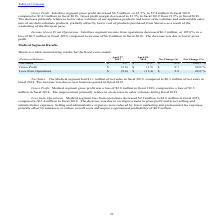According to Methode Electronics's financial document, What led to improvement in medical segment gross profit during fiscal 2019? an increase in sales volumes during fiscal 2019.. The document states: "fiscal 2018. The improvement primarily relates to an increase in sales volumes during fiscal 2019...." Also, can you calculate: What is the average Gross Profit for Fiscal Year Ended April 28, 2018 to Fiscal Year Ended April 27, 2019? To answer this question, I need to perform calculations using the financial data. The calculation is: -(2.8+3.5) / 2, which equals -3.15 (in millions). This is based on the information: "Gross Profit $ (2.8) $ (3.5) $ 0.7 20.0 % in fiscal 2018. Gross profit margin decreased to 13.5% in fiscal 2019 from 19.5% in fiscal 2018. The decrease primarily relates to lower sales volumes of..." The key data points involved are: 2.8, 3.5. Also, can you calculate: What is the average Loss from Operations for Fiscal Year Ended April 28, 2018 to Fiscal Year Ended April 27, 2019? To answer this question, I need to perform calculations using the financial data. The calculation is: -(8.6+11.4) / 2, which equals -10 (in millions). This is based on the information: "Loss from Operations $ (8.6) $ (11.4) $ 2.8 24.6 % Loss from Operations $ (8.6) $ (11.4) $ 2.8 24.6 %..." The key data points involved are: 11.4, 8.6. Additionally, In which period was net sales less than 1.0 million? According to the financial document, 2018. The relevant text states: "compared to $14.3 million in fiscal 2018. Gross profit margin decreased to 13.5% in fiscal 2019 from 19.5% in fiscal 2018. The decrease prim..." Also, What was the Gross Profit in 2019 and 2018 respectively? The document shows two values: $(2.8) and $(3.5) (in millions). From the document: "Gross Profit $ (2.8) $ (3.5) $ 0.7 20.0 % Gross Profit $ (2.8) $ (3.5) $ 0.7 20.0 %..." Also, What was the net sales from medical segment in 2019? According to the financial document, $1.1 million. The relevant text states: "Net Sales . The Medical segment had $1.1 million of net sales in fiscal 2019, compared to $0.3 million of net sales in..." 